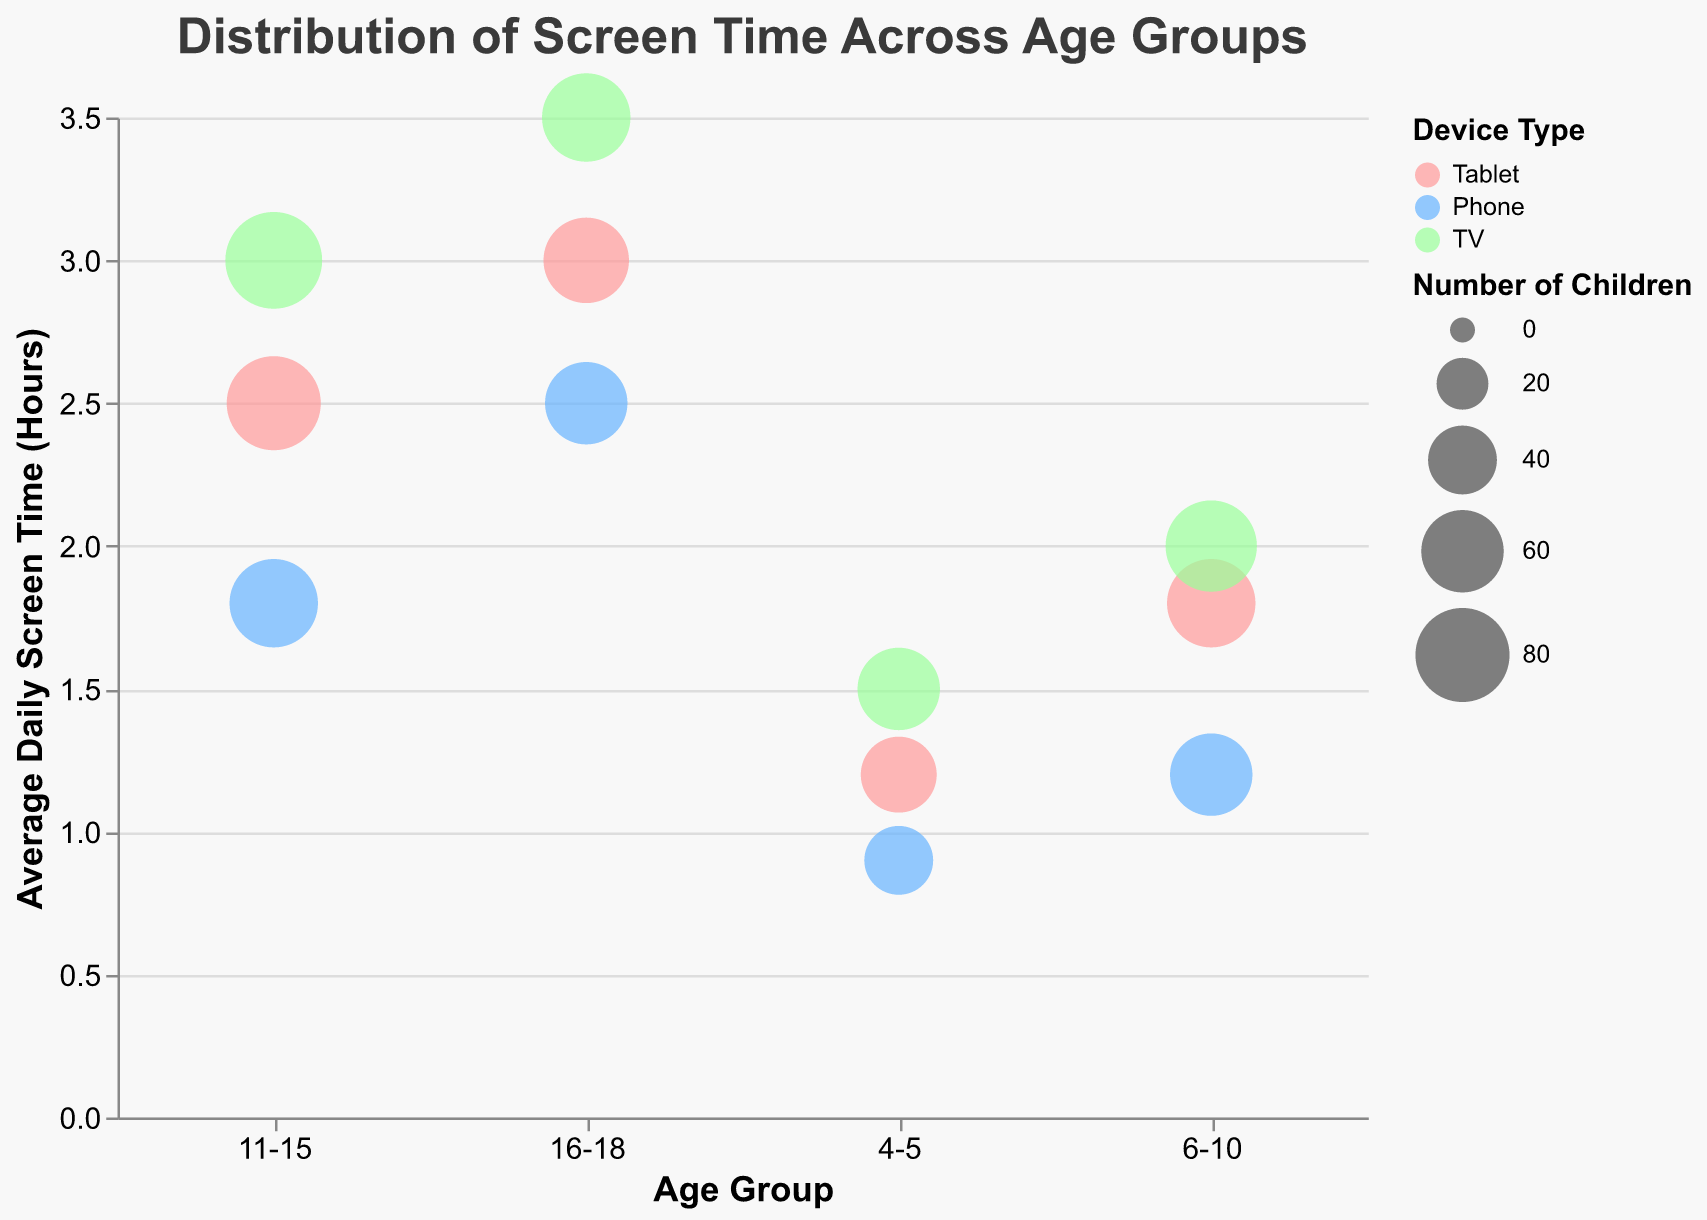What's the title of the figure? The title can be seen at the top of the chart, it states "Distribution of Screen Time Across Age Groups"
Answer: Distribution of Screen Time Across Age Groups What is the color representing the "Phone" device type? The "Phone" device type is associated with the blue color according to the legend on the right side of the chart.
Answer: Blue What age group has the highest average daily screen time on TV? Look at the y-axis values for the TV category and find the highest value. The 16-18 age group has the highest average daily screen time on TV with 3.5 hours.
Answer: 16-18 Which device type has the largest bubble size in the 11-15 age group? Bubble size represents the number of children. For the 11-15 age group, the largest bubble (most children) is for TV with 85 children.
Answer: TV How many age groups are represented in the chart? The x-axis lists the age groups. They are 4-5, 6-10, 11-15, and 16-18, totaling 4 age groups.
Answer: 4 What is the average daily screen time for the "Tablet" device in the 4-5 age group? Locate the bubble for the "Tablet" device type in the 4-5 age group; the y-axis value is 1.2 hours.
Answer: 1.2 hours Which device type has the smallest bubble size in the 6-10 age group? Bubble size represents the number of children. For the 6-10 age group, the smallest bubble is for "Phone" with 60 children.
Answer: Phone Compare the average daily screen time between "Phone" and "Tablet" for the 16-18 age group. Which one has a higher value? Look at the y-axis values for "Phone" and "Tablet" in the 16-18 age group. "Tablet" has 3.0 hours while "Phone" has 2.5 hours. Thus, "Tablet" has a higher value.
Answer: Tablet What is the total number of children in the 6-10 age group across all device types? Sum the "Number of Children" for all device types in the 6-10 age group: 70 (Tablet) + 60 (Phone) + 75 (TV) = 205.
Answer: 205 In which age group does "TV" have the highest average daily screen time? Look at the y-axis value for "TV" for each age group. The 16-18 age group has the highest average daily screen time for "TV" with 3.5 hours.
Answer: 16-18 